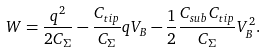Convert formula to latex. <formula><loc_0><loc_0><loc_500><loc_500>W = \frac { q ^ { 2 } } { 2 C _ { \Sigma } } - \frac { { C _ { t i p } } } { C _ { \Sigma } } q V _ { B } - \frac { 1 } { 2 } \frac { C _ { s u b } C _ { t i p } } { C _ { \Sigma } } V _ { B } ^ { 2 } .</formula> 